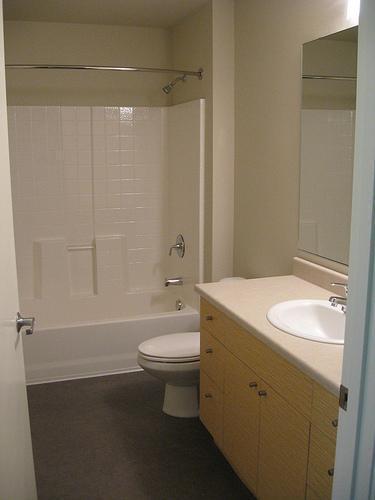How many sinks are there?
Give a very brief answer. 1. 